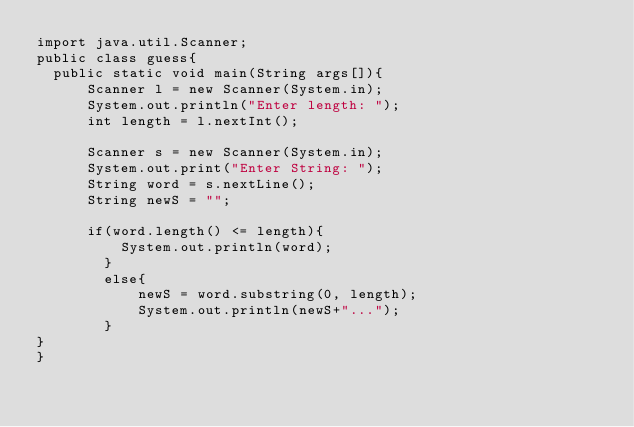Convert code to text. <code><loc_0><loc_0><loc_500><loc_500><_Java_>import java.util.Scanner;
public class guess{
  public static void main(String args[]){
      Scanner l = new Scanner(System.in);
      System.out.println("Enter length: ");
      int length = l.nextInt();
      
      Scanner s = new Scanner(System.in);
      System.out.print("Enter String: ");
      String word = s.nextLine();
      String newS = "";
      
      if(word.length() <= length){
          System.out.println(word);
        }
        else{
            newS = word.substring(0, length);
            System.out.println(newS+"...");
        }
}
}
</code> 